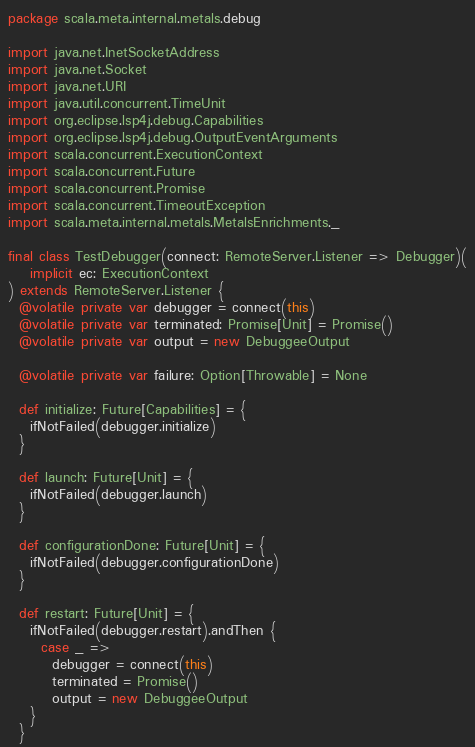Convert code to text. <code><loc_0><loc_0><loc_500><loc_500><_Scala_>package scala.meta.internal.metals.debug

import java.net.InetSocketAddress
import java.net.Socket
import java.net.URI
import java.util.concurrent.TimeUnit
import org.eclipse.lsp4j.debug.Capabilities
import org.eclipse.lsp4j.debug.OutputEventArguments
import scala.concurrent.ExecutionContext
import scala.concurrent.Future
import scala.concurrent.Promise
import scala.concurrent.TimeoutException
import scala.meta.internal.metals.MetalsEnrichments._

final class TestDebugger(connect: RemoteServer.Listener => Debugger)(
    implicit ec: ExecutionContext
) extends RemoteServer.Listener {
  @volatile private var debugger = connect(this)
  @volatile private var terminated: Promise[Unit] = Promise()
  @volatile private var output = new DebuggeeOutput

  @volatile private var failure: Option[Throwable] = None

  def initialize: Future[Capabilities] = {
    ifNotFailed(debugger.initialize)
  }

  def launch: Future[Unit] = {
    ifNotFailed(debugger.launch)
  }

  def configurationDone: Future[Unit] = {
    ifNotFailed(debugger.configurationDone)
  }

  def restart: Future[Unit] = {
    ifNotFailed(debugger.restart).andThen {
      case _ =>
        debugger = connect(this)
        terminated = Promise()
        output = new DebuggeeOutput
    }
  }
</code> 